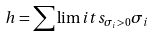<formula> <loc_0><loc_0><loc_500><loc_500>h = \sum \lim i t s _ { \sigma _ { i } > 0 } { \sigma _ { i } }</formula> 